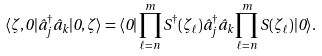Convert formula to latex. <formula><loc_0><loc_0><loc_500><loc_500>\langle \zeta , 0 | \hat { a } _ { j } ^ { \dagger } \hat { a } _ { k } | 0 , \zeta \rangle = \langle 0 | \prod _ { \ell = n } ^ { m } S ^ { \dagger } ( \zeta _ { \ell } ) \hat { a } _ { j } ^ { \dagger } \hat { a } _ { k } \prod _ { \ell = n } ^ { m } S ( \zeta _ { \ell } ) | 0 \rangle .</formula> 